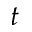Convert formula to latex. <formula><loc_0><loc_0><loc_500><loc_500>t</formula> 